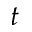Convert formula to latex. <formula><loc_0><loc_0><loc_500><loc_500>t</formula> 